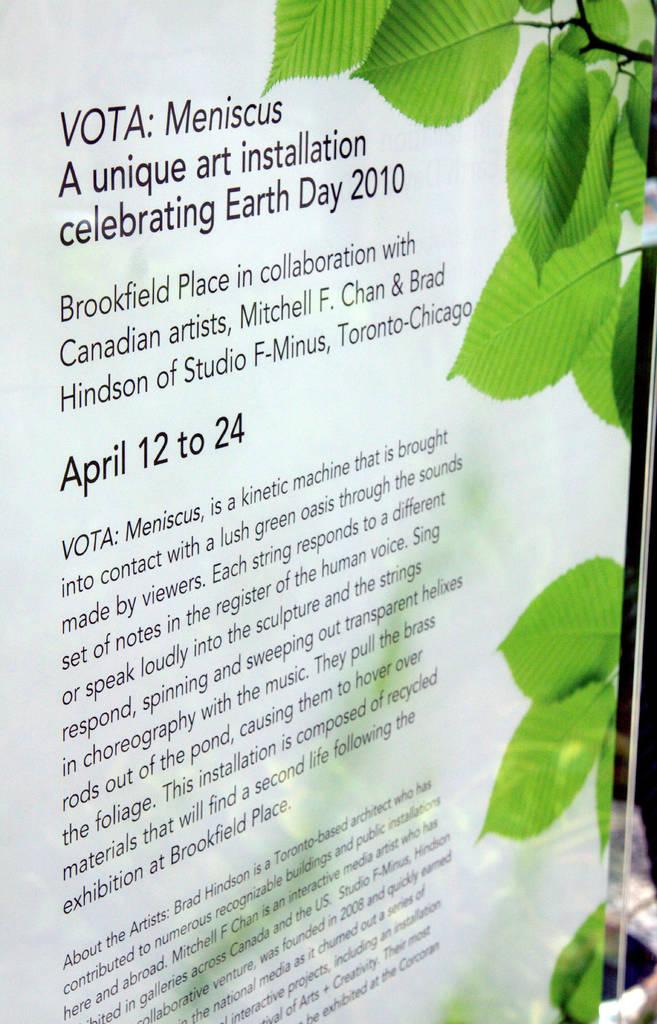What is the main object in the image? There is a whiteboard in the image. What is written or drawn on the whiteboard? The whiteboard has text on it. Are there any other elements in the image besides the whiteboard? Yes, there are leaves of a plant in the right corner of the image. How many thumbs are visible in the image? There are no thumbs visible in the image. Can you see a flock of birds flying in the image? There are no birds or flocks present in the image. 